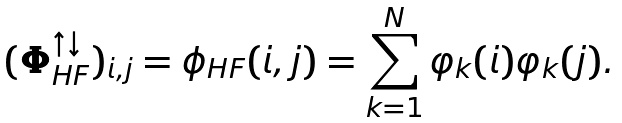Convert formula to latex. <formula><loc_0><loc_0><loc_500><loc_500>( \boldsymbol \Phi _ { H F } ^ { \uparrow \downarrow } ) _ { i , j } = \phi _ { H F } ( i , j ) = \sum _ { k = 1 } ^ { N } \varphi _ { k } ( i ) \varphi _ { k } ( j ) .</formula> 